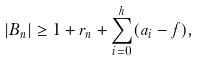<formula> <loc_0><loc_0><loc_500><loc_500>\left | B _ { n } \right | \geq 1 + r _ { n } + \sum _ { i = 0 } ^ { h } ( a _ { i } - f ) ,</formula> 